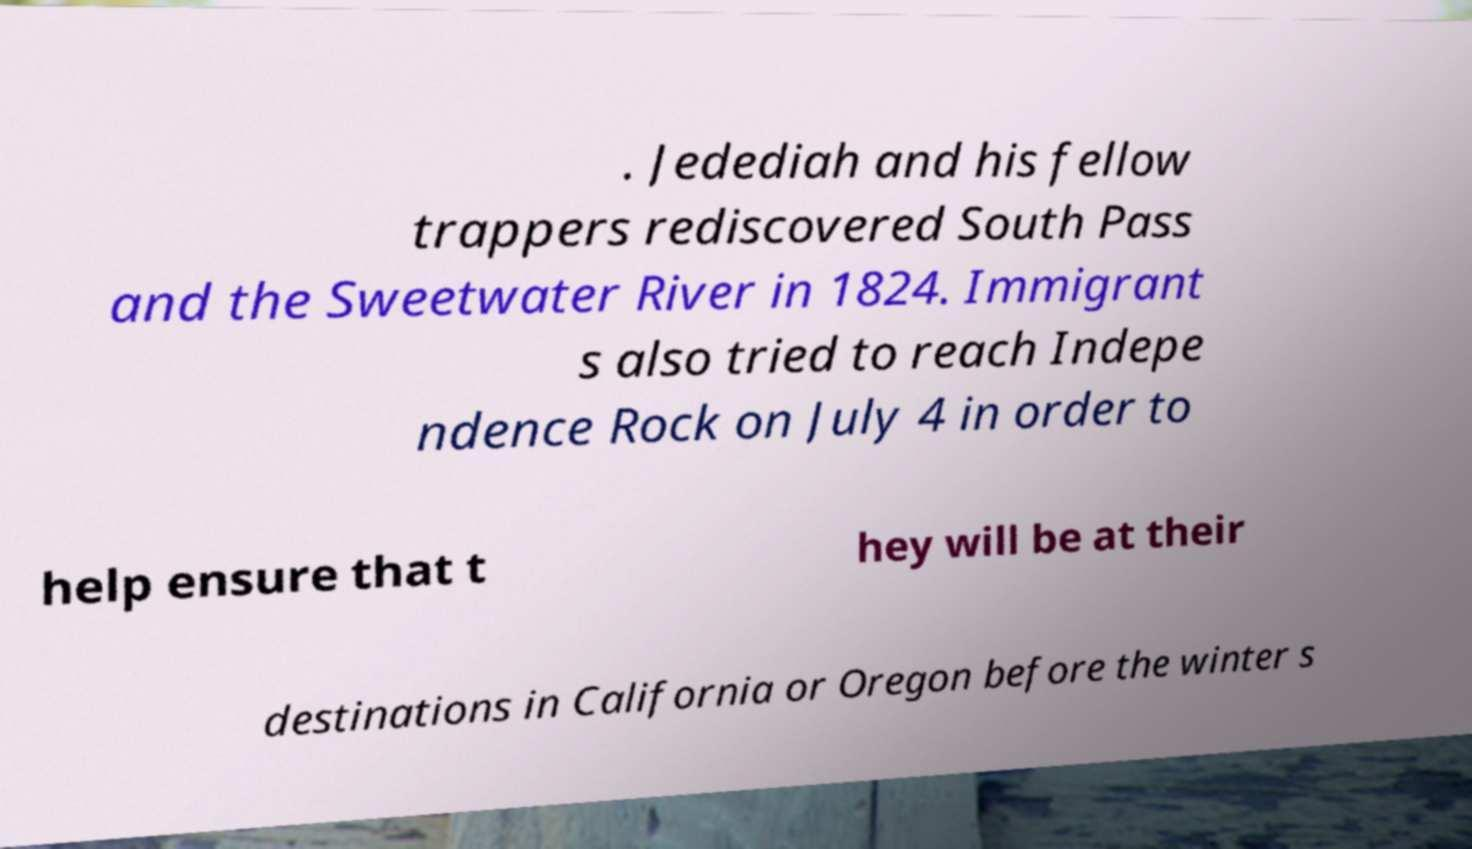For documentation purposes, I need the text within this image transcribed. Could you provide that? . Jedediah and his fellow trappers rediscovered South Pass and the Sweetwater River in 1824. Immigrant s also tried to reach Indepe ndence Rock on July 4 in order to help ensure that t hey will be at their destinations in California or Oregon before the winter s 